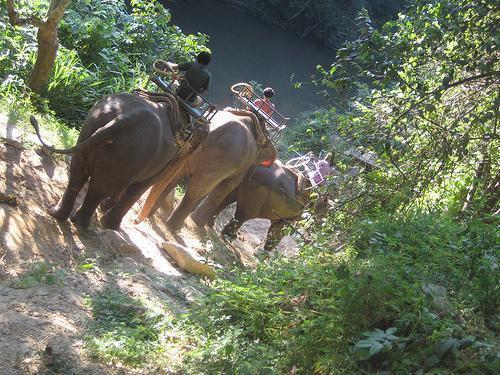How many elephants are there?
Give a very brief answer. 3. 